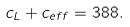<formula> <loc_0><loc_0><loc_500><loc_500>c _ { L } + c _ { e f f } = 3 8 8 .</formula> 